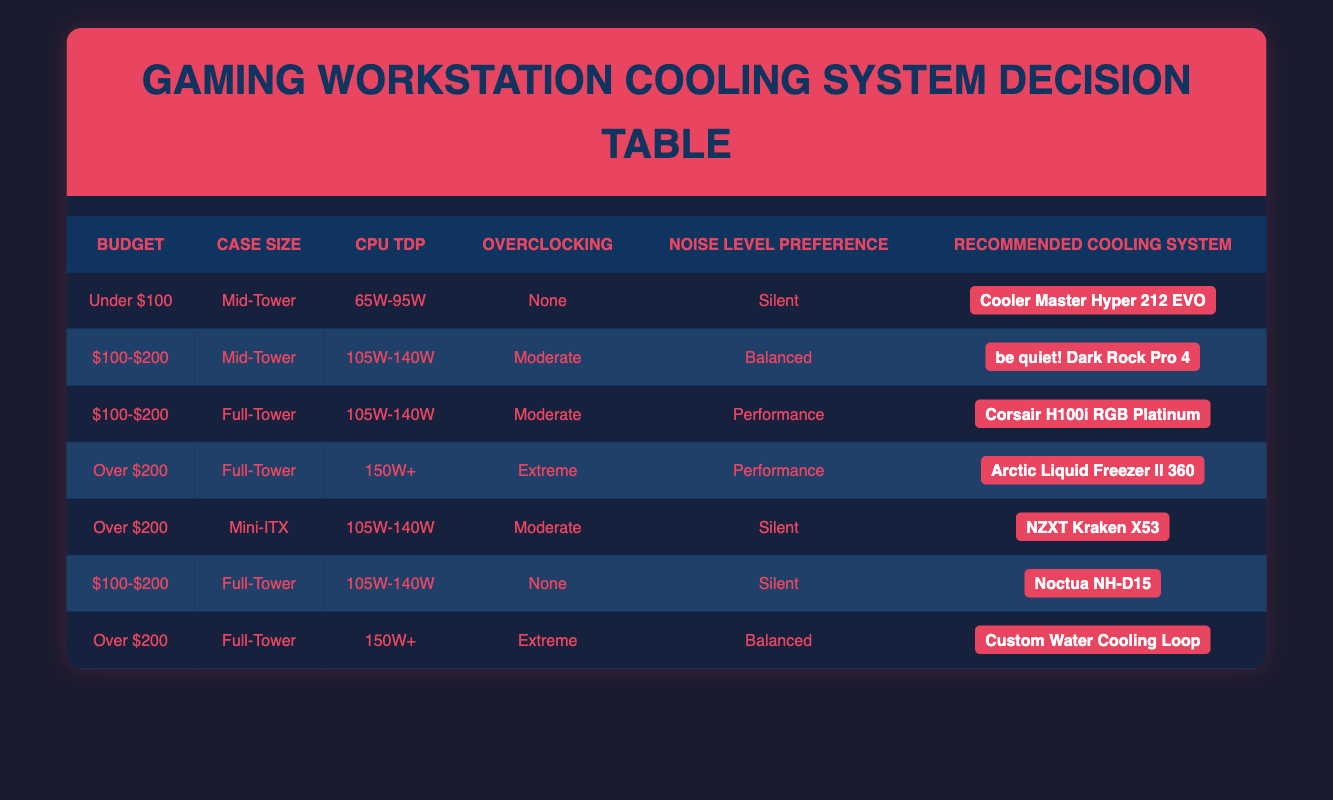What cooling system is recommended for a Full-Tower case with a budget over $200 and 150W+ TDP? From the table, under the conditions of "Over $200," "Full-Tower," and "150W+ TDP," the recommended cooling system is "Arctic Liquid Freezer II 360."
Answer: Arctic Liquid Freezer II 360 Which cooling system should I choose if I want a silent operation and a budget of under $100? According to the table, for a budget "Under $100," with the condition of "Mid-Tower," "65W-95W TDP," "None" overclocking, and "Silent" preference, the cooling system choice is "Cooler Master Hyper 212 EVO."
Answer: Cooler Master Hyper 212 EVO In what scenarios would the Corsair H100i RGB Platinum be recommended? The table shows that Corsair H100i RGB Platinum is recommended when the budget is between "$100-$200," the case size is "Full-Tower," the CPU TDP is "105W-140W," with "Moderate" overclocking, and a "Performance" noise level preference. This is just one scenario; it could be inferred that other scenarios exist as well.
Answer: Budget $100-$200, Full-Tower, 105W-140W TDP, Moderate, Performance Is overclocking necessary if I want to use the Noctua NH-D15? From the table, the Noctua NH-D15 is recommended for the condition of "$100-$200," "Full-Tower," "105W-140W TDP," with "None" overclocking, meaning overclocking is not necessary to use this cooling system.
Answer: No What is the total number of cooling systems recommended for cases under a budget of $200? There are three entries for cases under a budget of $200 in the table. These are for Cooler Master Hyper 212 EVO, be quiet! Dark Rock Pro 4, and Noctua NH-D15. Therefore, we count these to determine the total number.
Answer: 3 For a Mini-ITX setup with moderate overclocking and a silent noise preference, which cooling system should be used? Looking at the table, for "Over $200" budget, "Mini-ITX" case size, "105W-140W TDP," with "Moderate" overclocking, and "Silent" preference, the recommended cooling system is "NZXT Kraken X53."
Answer: NZXT Kraken X53 Can you find out how many systems cater to "Balanced" noise level preference? Upon reviewing the table, two cooling systems appear under "Balanced" for the condition of "$100-$200, Mid-Tower, 105W-140W TDP, Moderate" and "Over $200, Full-Tower, 150W+, Extreme." These systems provide options for balanced noise levels.
Answer: 2 Does the table suggest a cooling system for a Full-Tower case with extreme overclocking but under a $100 budget? The table indicates that there are no recommendations for a Full-Tower case with extreme overclocking under a $100 budget, as most extreme setups require a higher budget than available.
Answer: No 